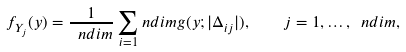<formula> <loc_0><loc_0><loc_500><loc_500>f _ { Y _ { j } } ( y ) = \frac { 1 } { \ n d i m } \sum _ { i = 1 } ^ { \ } n d i m g ( y ; | \Delta _ { i j } | ) , \quad j = 1 , \dots , \ n d i m ,</formula> 